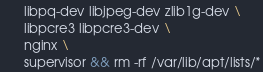Convert code to text. <code><loc_0><loc_0><loc_500><loc_500><_Dockerfile_>      libpq-dev libjpeg-dev zlib1g-dev \
      libpcre3 libpcre3-dev \
      nginx \
      supervisor && rm -rf /var/lib/apt/lists/*
</code> 